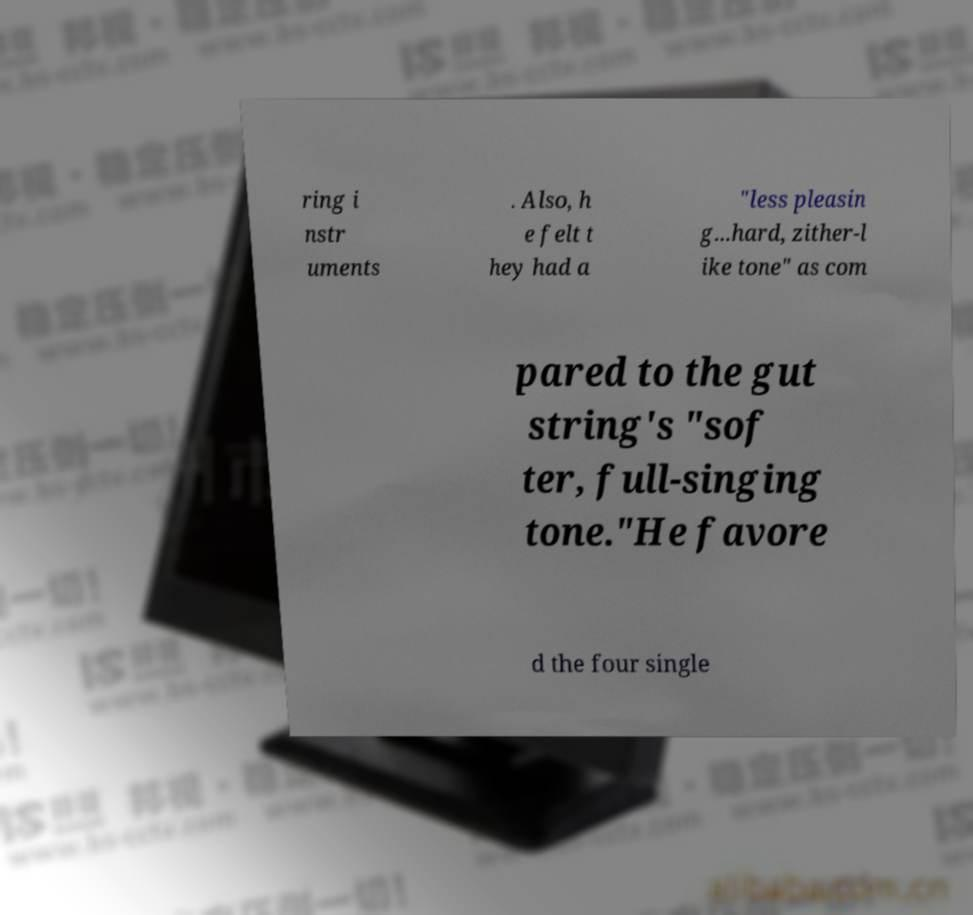There's text embedded in this image that I need extracted. Can you transcribe it verbatim? ring i nstr uments . Also, h e felt t hey had a "less pleasin g...hard, zither-l ike tone" as com pared to the gut string's "sof ter, full-singing tone."He favore d the four single 